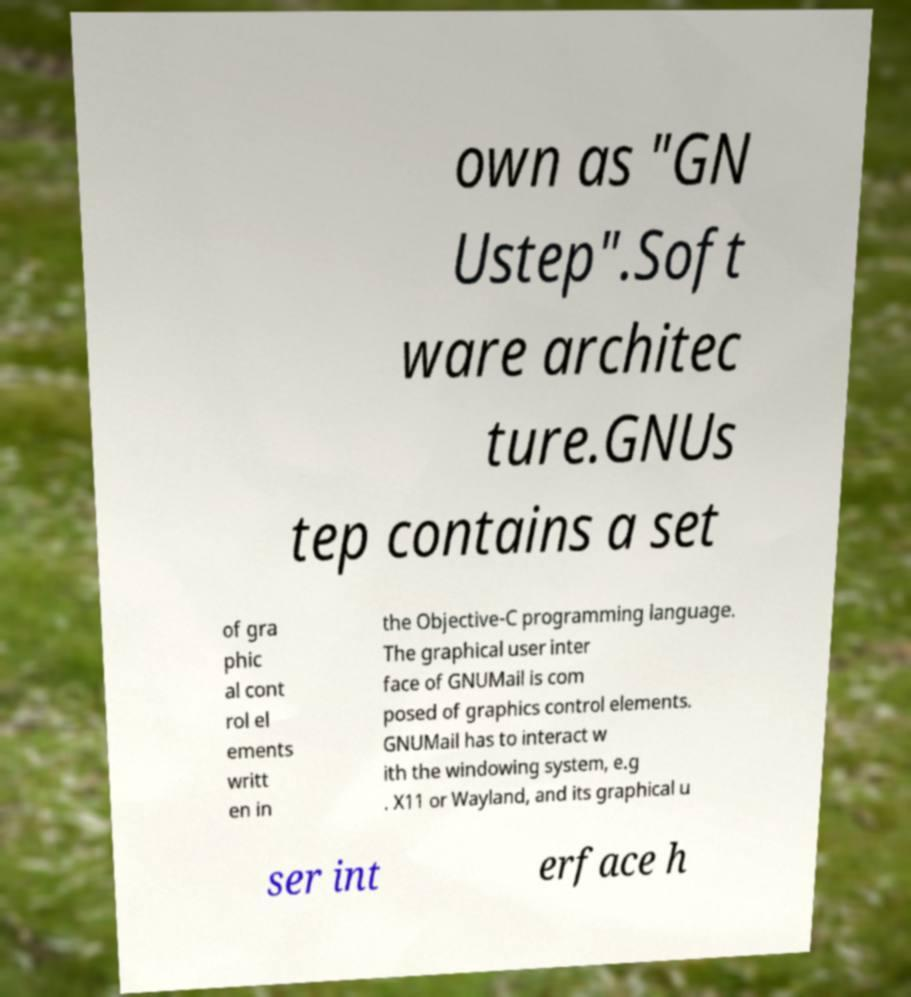Can you accurately transcribe the text from the provided image for me? own as "GN Ustep".Soft ware architec ture.GNUs tep contains a set of gra phic al cont rol el ements writt en in the Objective-C programming language. The graphical user inter face of GNUMail is com posed of graphics control elements. GNUMail has to interact w ith the windowing system, e.g . X11 or Wayland, and its graphical u ser int erface h 